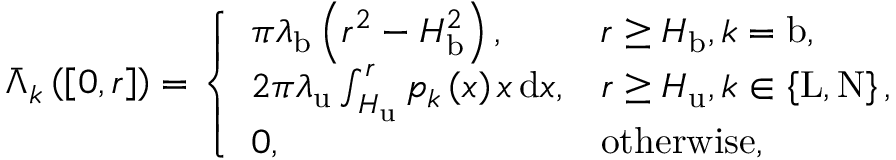Convert formula to latex. <formula><loc_0><loc_0><loc_500><loc_500>\begin{array} { r } { \bar { \Lambda } _ { k } \left ( \left [ 0 , r \right ] \right ) = \left \{ \begin{array} { l l } { \pi \lambda _ { b } \left ( r ^ { 2 } - H _ { b } ^ { 2 } \right ) , } & { r \geq H _ { b } , k = b , } \\ { 2 \pi \lambda _ { u } \int _ { H _ { u } } ^ { r } { p _ { k } \left ( x \right ) x \, d x } , } & { r \geq H _ { u } , k \in \left \{ L , N \right \} , } \\ { 0 , } & { o t h e r w i s e , } \end{array} } \end{array}</formula> 